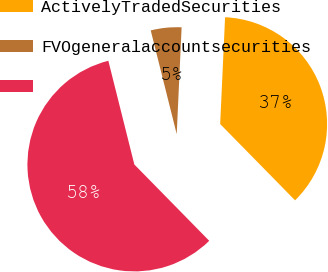Convert chart. <chart><loc_0><loc_0><loc_500><loc_500><pie_chart><fcel>ActivelyTradedSecurities<fcel>FVOgeneralaccountsecurities<fcel>Unnamed: 2<nl><fcel>36.92%<fcel>4.64%<fcel>58.44%<nl></chart> 